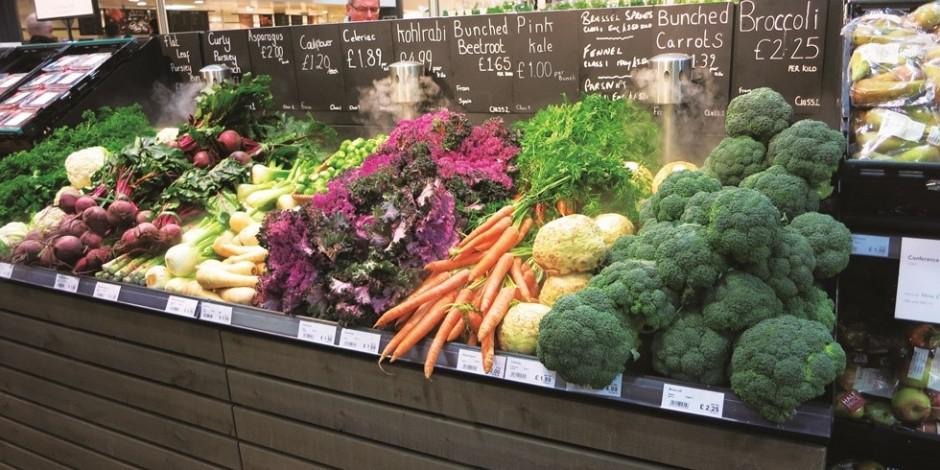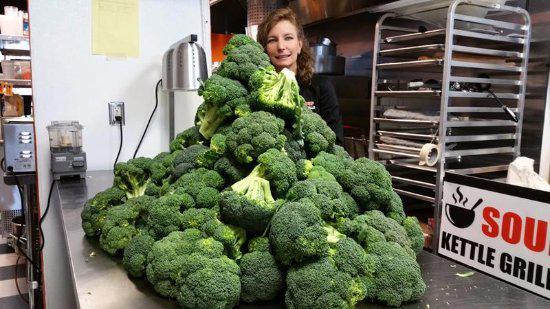The first image is the image on the left, the second image is the image on the right. Evaluate the accuracy of this statement regarding the images: "All images show broccoli in a round container of some type.". Is it true? Answer yes or no. No. The first image is the image on the left, the second image is the image on the right. Assess this claim about the two images: "There is a human head in the image on the right.". Correct or not? Answer yes or no. Yes. 